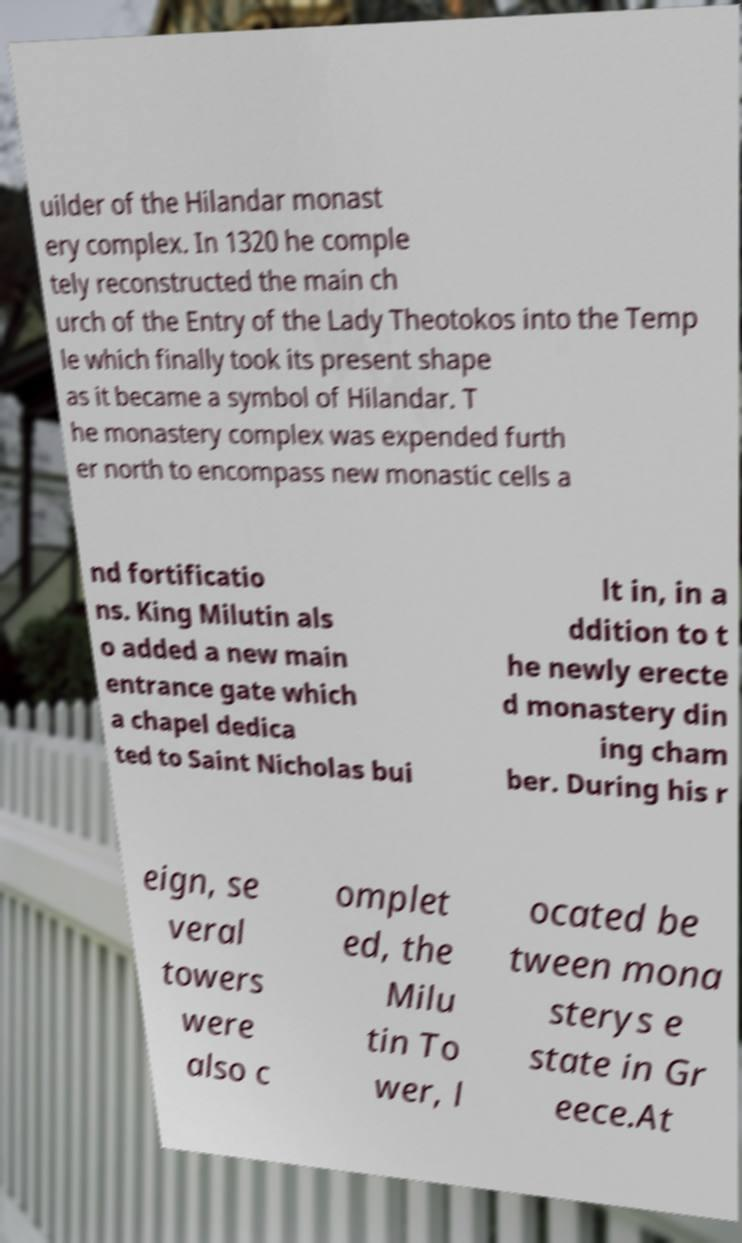Could you extract and type out the text from this image? uilder of the Hilandar monast ery complex. In 1320 he comple tely reconstructed the main ch urch of the Entry of the Lady Theotokos into the Temp le which finally took its present shape as it became a symbol of Hilandar. T he monastery complex was expended furth er north to encompass new monastic cells a nd fortificatio ns. King Milutin als o added a new main entrance gate which a chapel dedica ted to Saint Nicholas bui lt in, in a ddition to t he newly erecte d monastery din ing cham ber. During his r eign, se veral towers were also c omplet ed, the Milu tin To wer, l ocated be tween mona sterys e state in Gr eece.At 